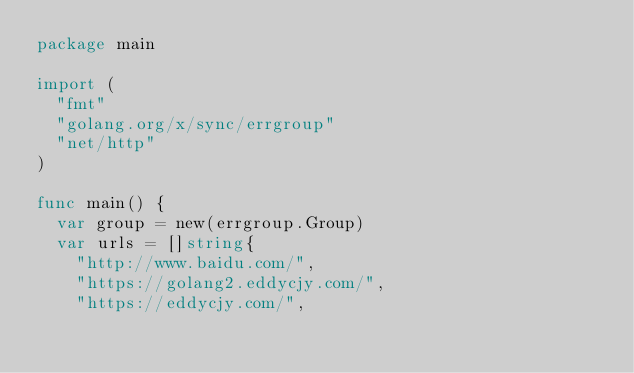<code> <loc_0><loc_0><loc_500><loc_500><_Go_>package main

import (
	"fmt"
	"golang.org/x/sync/errgroup"
	"net/http"
)

func main() {
	var group = new(errgroup.Group)
	var urls = []string{
		"http://www.baidu.com/",
		"https://golang2.eddycjy.com/",
		"https://eddycjy.com/",</code> 